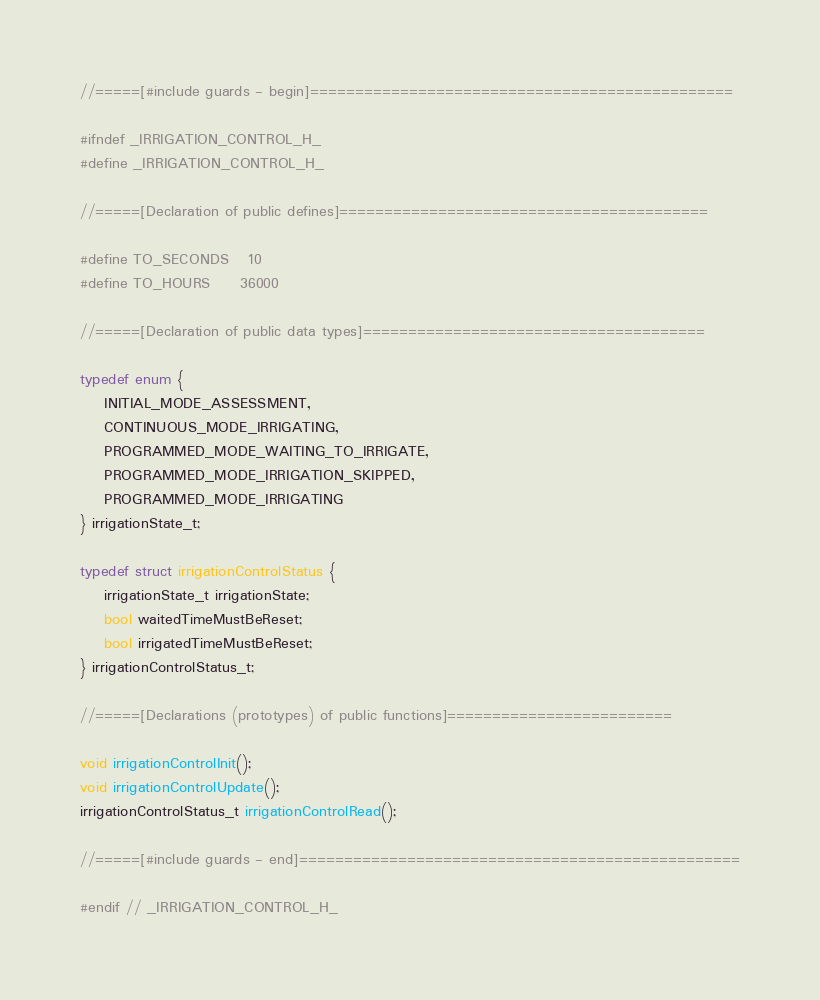Convert code to text. <code><loc_0><loc_0><loc_500><loc_500><_C_>//=====[#include guards - begin]===============================================

#ifndef _IRRIGATION_CONTROL_H_
#define _IRRIGATION_CONTROL_H_

//=====[Declaration of public defines]=========================================

#define TO_SECONDS   10
#define TO_HOURS     36000

//=====[Declaration of public data types]======================================

typedef enum {
    INITIAL_MODE_ASSESSMENT, 
    CONTINUOUS_MODE_IRRIGATING, 
    PROGRAMMED_MODE_WAITING_TO_IRRIGATE, 
    PROGRAMMED_MODE_IRRIGATION_SKIPPED,
    PROGRAMMED_MODE_IRRIGATING
} irrigationState_t;

typedef struct irrigationControlStatus {
    irrigationState_t irrigationState;
    bool waitedTimeMustBeReset;
    bool irrigatedTimeMustBeReset;
} irrigationControlStatus_t;

//=====[Declarations (prototypes) of public functions]=========================

void irrigationControlInit();
void irrigationControlUpdate();
irrigationControlStatus_t irrigationControlRead();

//=====[#include guards - end]=================================================

#endif // _IRRIGATION_CONTROL_H_</code> 